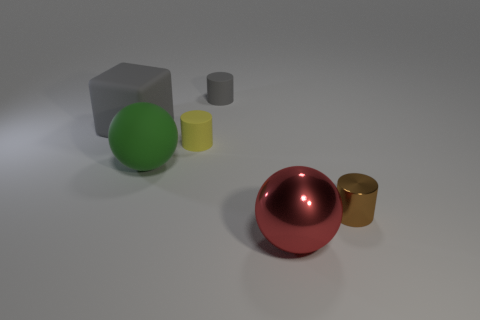Add 2 yellow matte blocks. How many objects exist? 8 Subtract all cubes. How many objects are left? 5 Subtract 0 blue cylinders. How many objects are left? 6 Subtract all yellow cylinders. Subtract all tiny yellow cylinders. How many objects are left? 4 Add 6 tiny cylinders. How many tiny cylinders are left? 9 Add 6 brown metallic cylinders. How many brown metallic cylinders exist? 7 